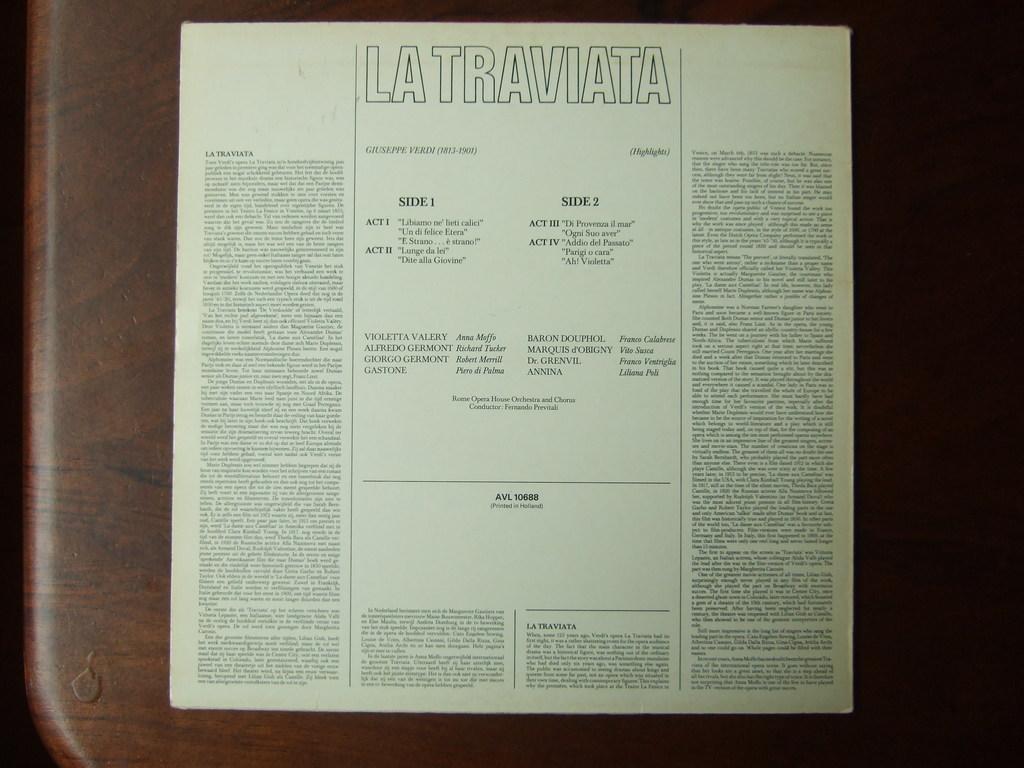What is the title of this document?
Give a very brief answer. La traviata. How many sides are there?
Your response must be concise. 2. 